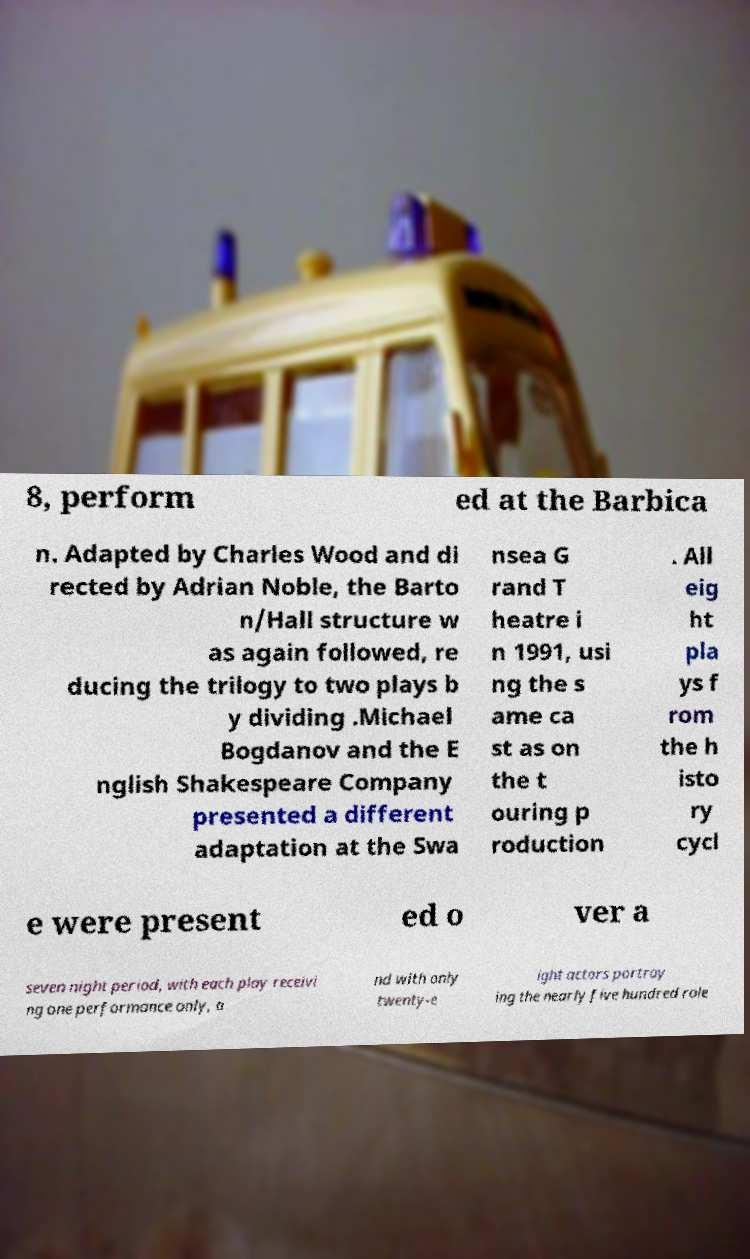Could you extract and type out the text from this image? 8, perform ed at the Barbica n. Adapted by Charles Wood and di rected by Adrian Noble, the Barto n/Hall structure w as again followed, re ducing the trilogy to two plays b y dividing .Michael Bogdanov and the E nglish Shakespeare Company presented a different adaptation at the Swa nsea G rand T heatre i n 1991, usi ng the s ame ca st as on the t ouring p roduction . All eig ht pla ys f rom the h isto ry cycl e were present ed o ver a seven night period, with each play receivi ng one performance only, a nd with only twenty-e ight actors portray ing the nearly five hundred role 